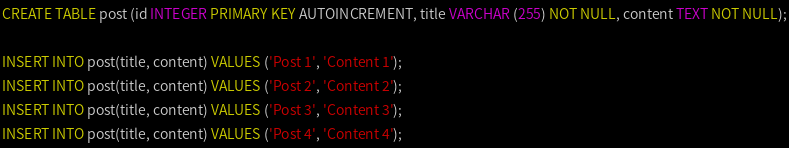Convert code to text. <code><loc_0><loc_0><loc_500><loc_500><_SQL_>CREATE TABLE post (id INTEGER PRIMARY KEY AUTOINCREMENT, title VARCHAR (255) NOT NULL, content TEXT NOT NULL);

INSERT INTO post(title, content) VALUES ('Post 1', 'Content 1');
INSERT INTO post(title, content) VALUES ('Post 2', 'Content 2');
INSERT INTO post(title, content) VALUES ('Post 3', 'Content 3');
INSERT INTO post(title, content) VALUES ('Post 4', 'Content 4');</code> 